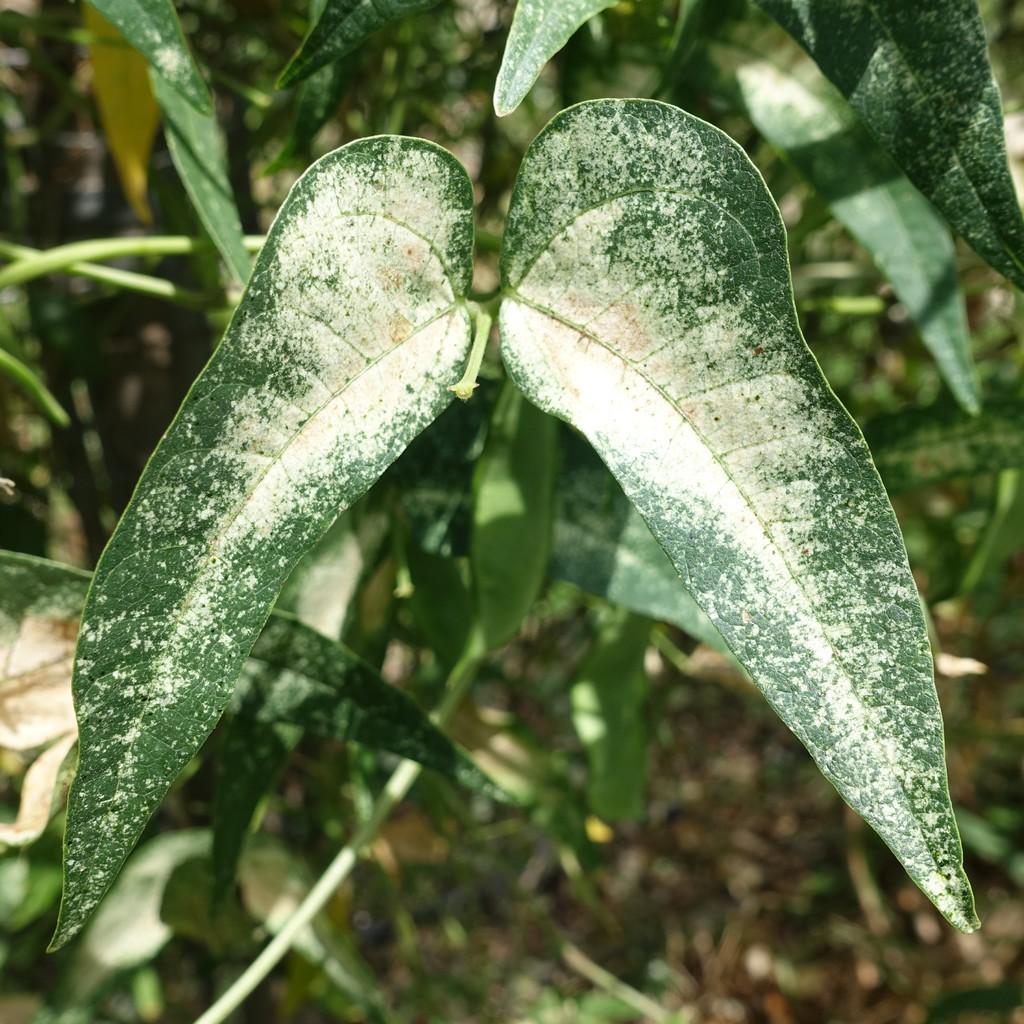In one or two sentences, can you explain what this image depicts? In this image we can see some trees and leaves on the surface. 